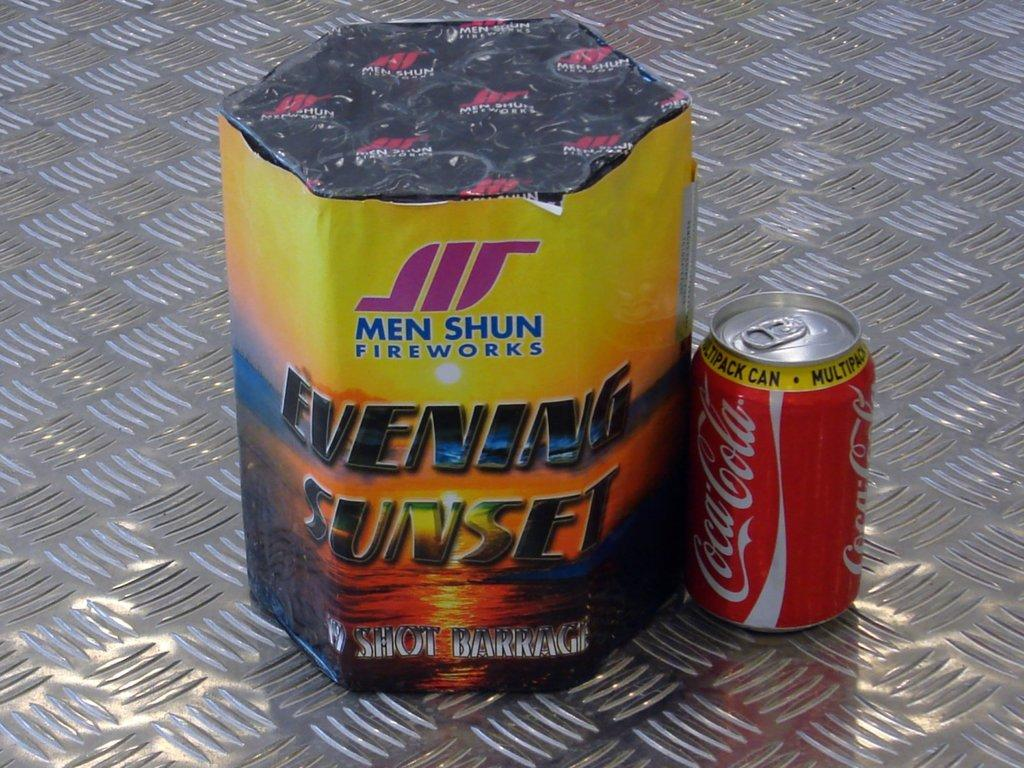<image>
Offer a succinct explanation of the picture presented. A coke can sitting next to a Men Shun firework. 